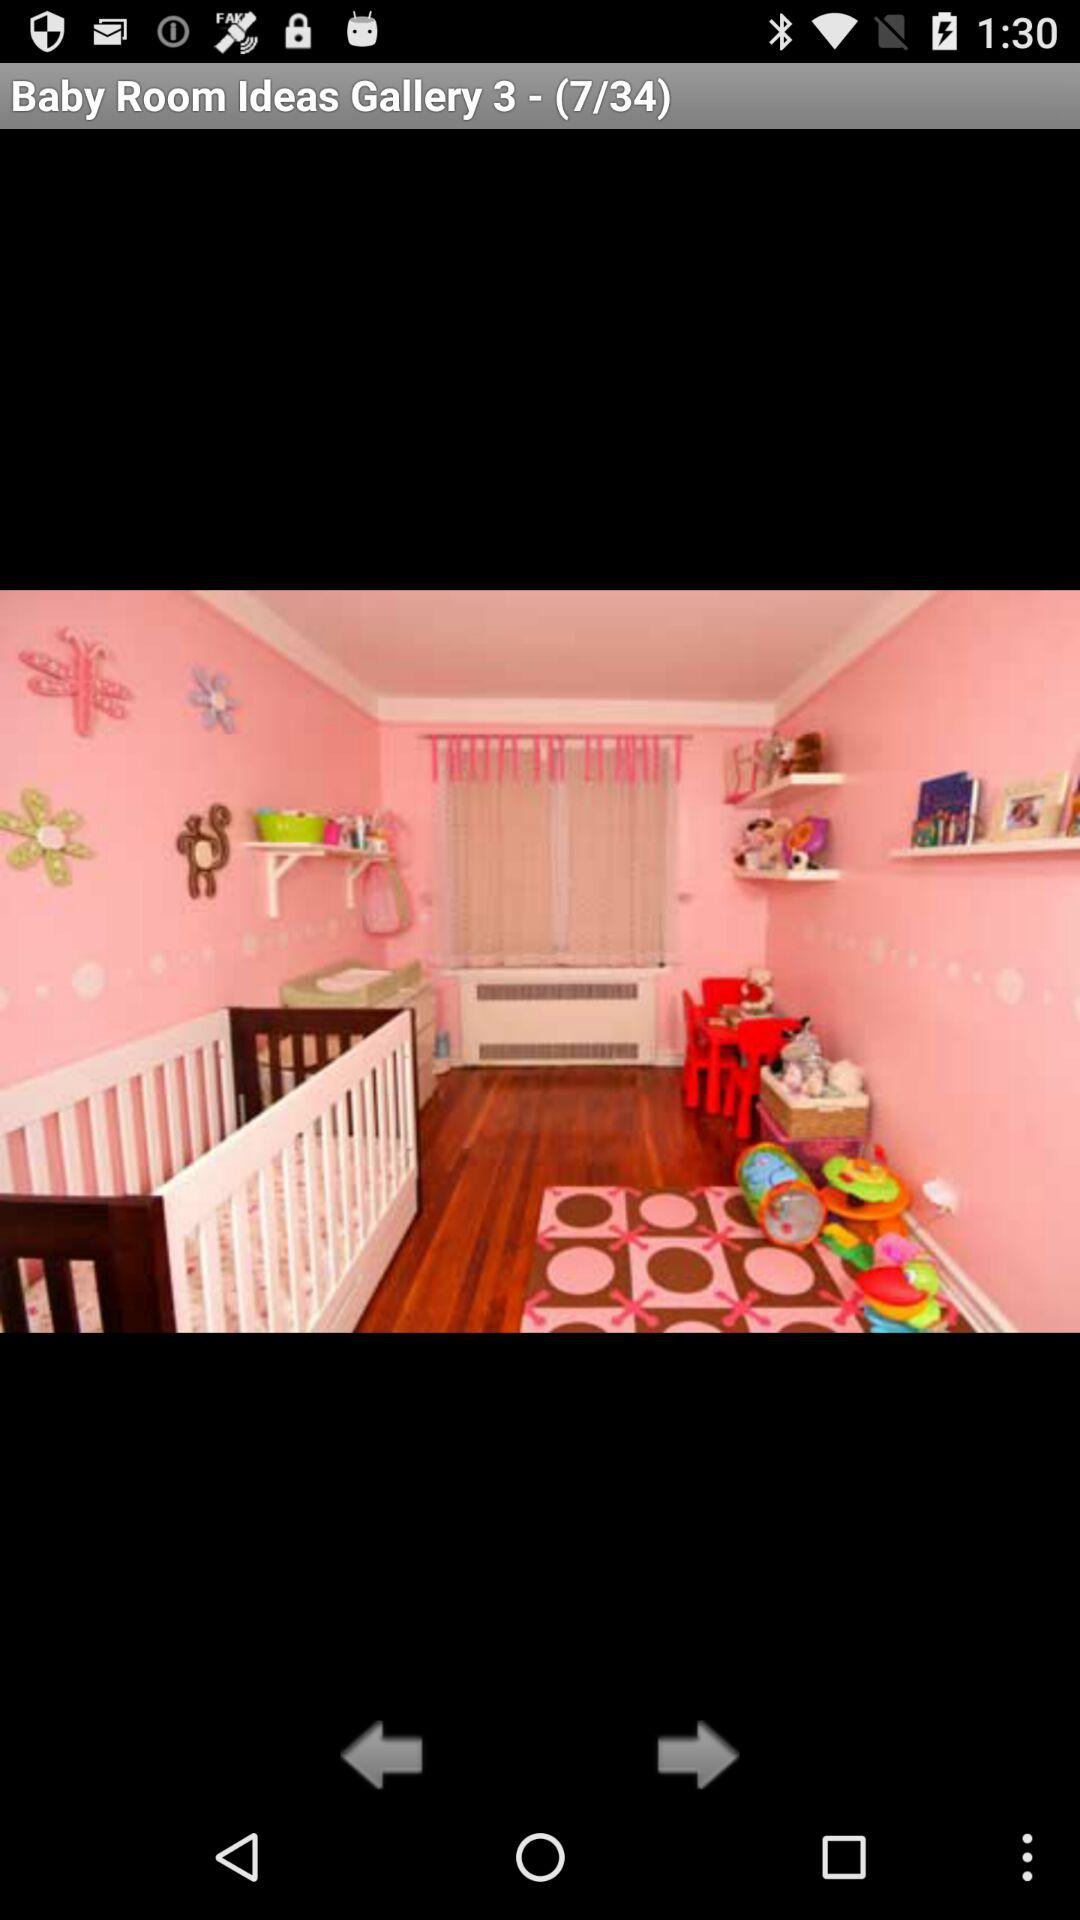Which image am I on? You are on image 7. 